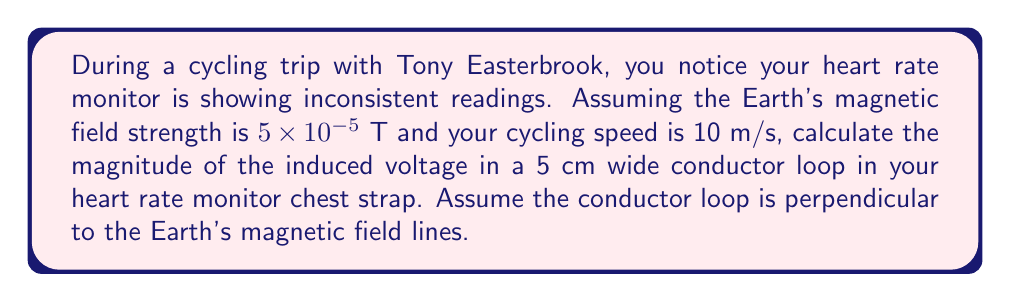Could you help me with this problem? To solve this problem, we'll use Faraday's law of electromagnetic induction:

$$\varepsilon = -\frac{d\Phi_B}{dt}$$

Where $\varepsilon$ is the induced voltage, and $\Phi_B$ is the magnetic flux.

1) First, we need to calculate the area of the conductor loop:
   $A = 0.05 \text{ m} \times 0.05 \text{ m} = 2.5 \times 10^{-3} \text{ m}^2$

2) The magnetic flux is given by:
   $$\Phi_B = B \cdot A \cdot \cos\theta$$
   Where $B$ is the magnetic field strength, $A$ is the area, and $\theta$ is the angle between the field lines and the normal to the loop (0° in this case as they're perpendicular).

3) As you cycle, the flux changes due to your motion. The rate of change of flux is:
   $$\frac{d\Phi_B}{dt} = \frac{d(BA\cos\theta)}{dt} = A\cos\theta \frac{dB}{dt}$$

4) The rate of change of the magnetic field $\frac{dB}{dt}$ is related to your cycling speed $v$:
   $$\frac{dB}{dt} = B \cdot \frac{v}{l}$$
   Where $l$ is the width of the loop (0.05 m).

5) Substituting all values:
   $$\varepsilon = -(2.5 \times 10^{-3} \text{ m}^2)(1)(5 \times 10^{-5} \text{ T})\frac{10 \text{ m/s}}{0.05 \text{ m}}$$

6) Calculating the final result:
   $$\varepsilon = -2.5 \times 10^{-4} \text{ V} = -0.25 \text{ mV}$$

The negative sign indicates the direction of the induced voltage, but for magnitude, we take the absolute value.
Answer: 0.25 mV 